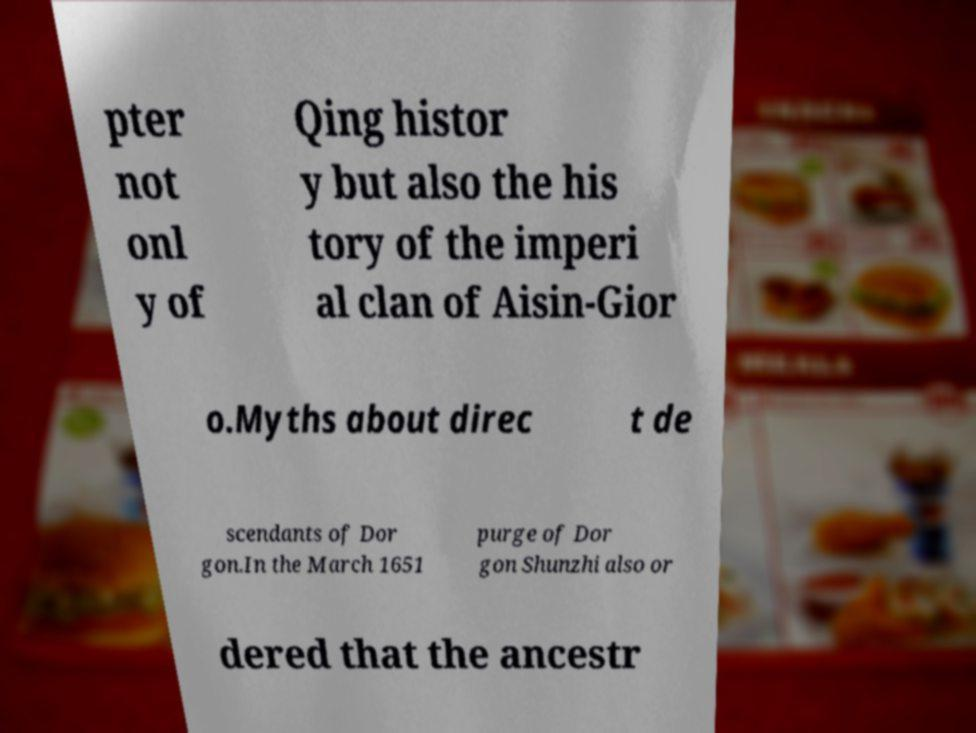Please read and relay the text visible in this image. What does it say? pter not onl y of Qing histor y but also the his tory of the imperi al clan of Aisin-Gior o.Myths about direc t de scendants of Dor gon.In the March 1651 purge of Dor gon Shunzhi also or dered that the ancestr 